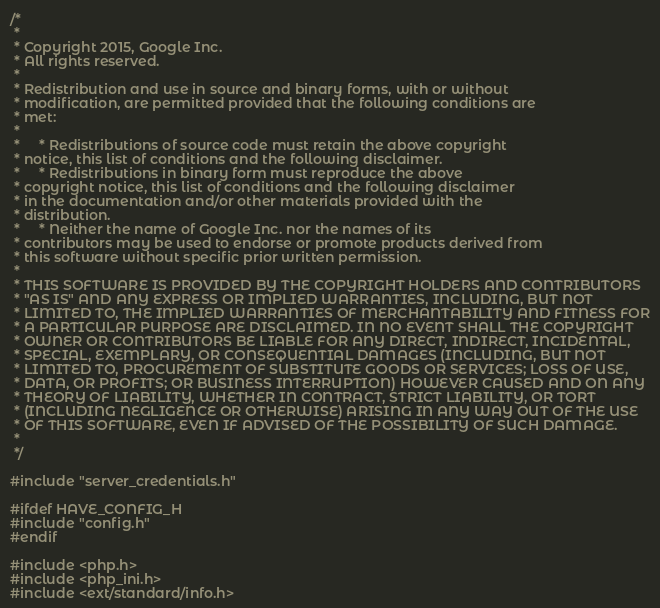<code> <loc_0><loc_0><loc_500><loc_500><_C_>/*
 *
 * Copyright 2015, Google Inc.
 * All rights reserved.
 *
 * Redistribution and use in source and binary forms, with or without
 * modification, are permitted provided that the following conditions are
 * met:
 *
 *     * Redistributions of source code must retain the above copyright
 * notice, this list of conditions and the following disclaimer.
 *     * Redistributions in binary form must reproduce the above
 * copyright notice, this list of conditions and the following disclaimer
 * in the documentation and/or other materials provided with the
 * distribution.
 *     * Neither the name of Google Inc. nor the names of its
 * contributors may be used to endorse or promote products derived from
 * this software without specific prior written permission.
 *
 * THIS SOFTWARE IS PROVIDED BY THE COPYRIGHT HOLDERS AND CONTRIBUTORS
 * "AS IS" AND ANY EXPRESS OR IMPLIED WARRANTIES, INCLUDING, BUT NOT
 * LIMITED TO, THE IMPLIED WARRANTIES OF MERCHANTABILITY AND FITNESS FOR
 * A PARTICULAR PURPOSE ARE DISCLAIMED. IN NO EVENT SHALL THE COPYRIGHT
 * OWNER OR CONTRIBUTORS BE LIABLE FOR ANY DIRECT, INDIRECT, INCIDENTAL,
 * SPECIAL, EXEMPLARY, OR CONSEQUENTIAL DAMAGES (INCLUDING, BUT NOT
 * LIMITED TO, PROCUREMENT OF SUBSTITUTE GOODS OR SERVICES; LOSS OF USE,
 * DATA, OR PROFITS; OR BUSINESS INTERRUPTION) HOWEVER CAUSED AND ON ANY
 * THEORY OF LIABILITY, WHETHER IN CONTRACT, STRICT LIABILITY, OR TORT
 * (INCLUDING NEGLIGENCE OR OTHERWISE) ARISING IN ANY WAY OUT OF THE USE
 * OF THIS SOFTWARE, EVEN IF ADVISED OF THE POSSIBILITY OF SUCH DAMAGE.
 *
 */

#include "server_credentials.h"

#ifdef HAVE_CONFIG_H
#include "config.h"
#endif

#include <php.h>
#include <php_ini.h>
#include <ext/standard/info.h></code> 